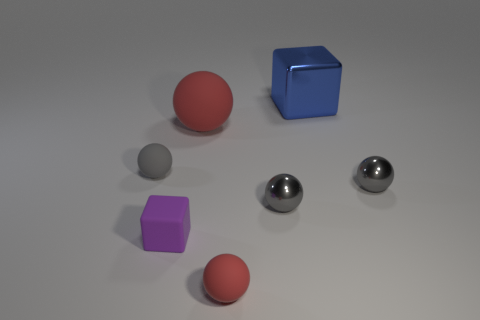Subtract all red blocks. How many gray spheres are left? 3 Subtract all gray matte balls. How many balls are left? 4 Subtract all cyan balls. Subtract all green cylinders. How many balls are left? 5 Add 2 small purple cylinders. How many objects exist? 9 Subtract all balls. How many objects are left? 2 Subtract all yellow cylinders. Subtract all tiny gray shiny objects. How many objects are left? 5 Add 7 rubber spheres. How many rubber spheres are left? 10 Add 4 large red rubber balls. How many large red rubber balls exist? 5 Subtract 0 cyan spheres. How many objects are left? 7 